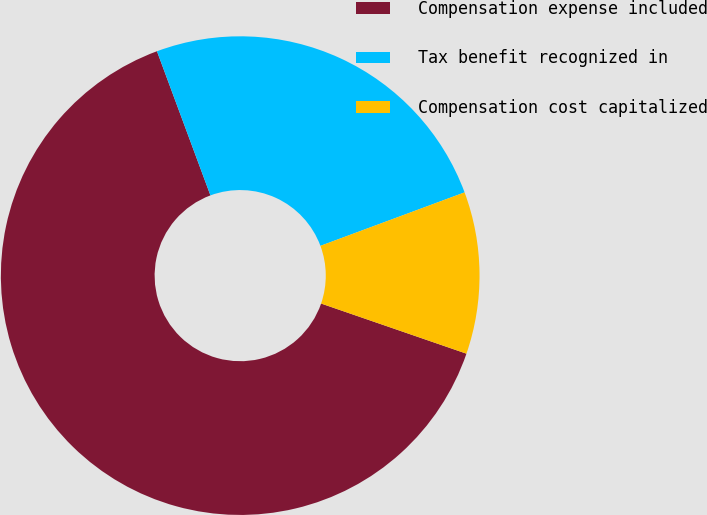Convert chart to OTSL. <chart><loc_0><loc_0><loc_500><loc_500><pie_chart><fcel>Compensation expense included<fcel>Tax benefit recognized in<fcel>Compensation cost capitalized<nl><fcel>64.06%<fcel>25.0%<fcel>10.94%<nl></chart> 